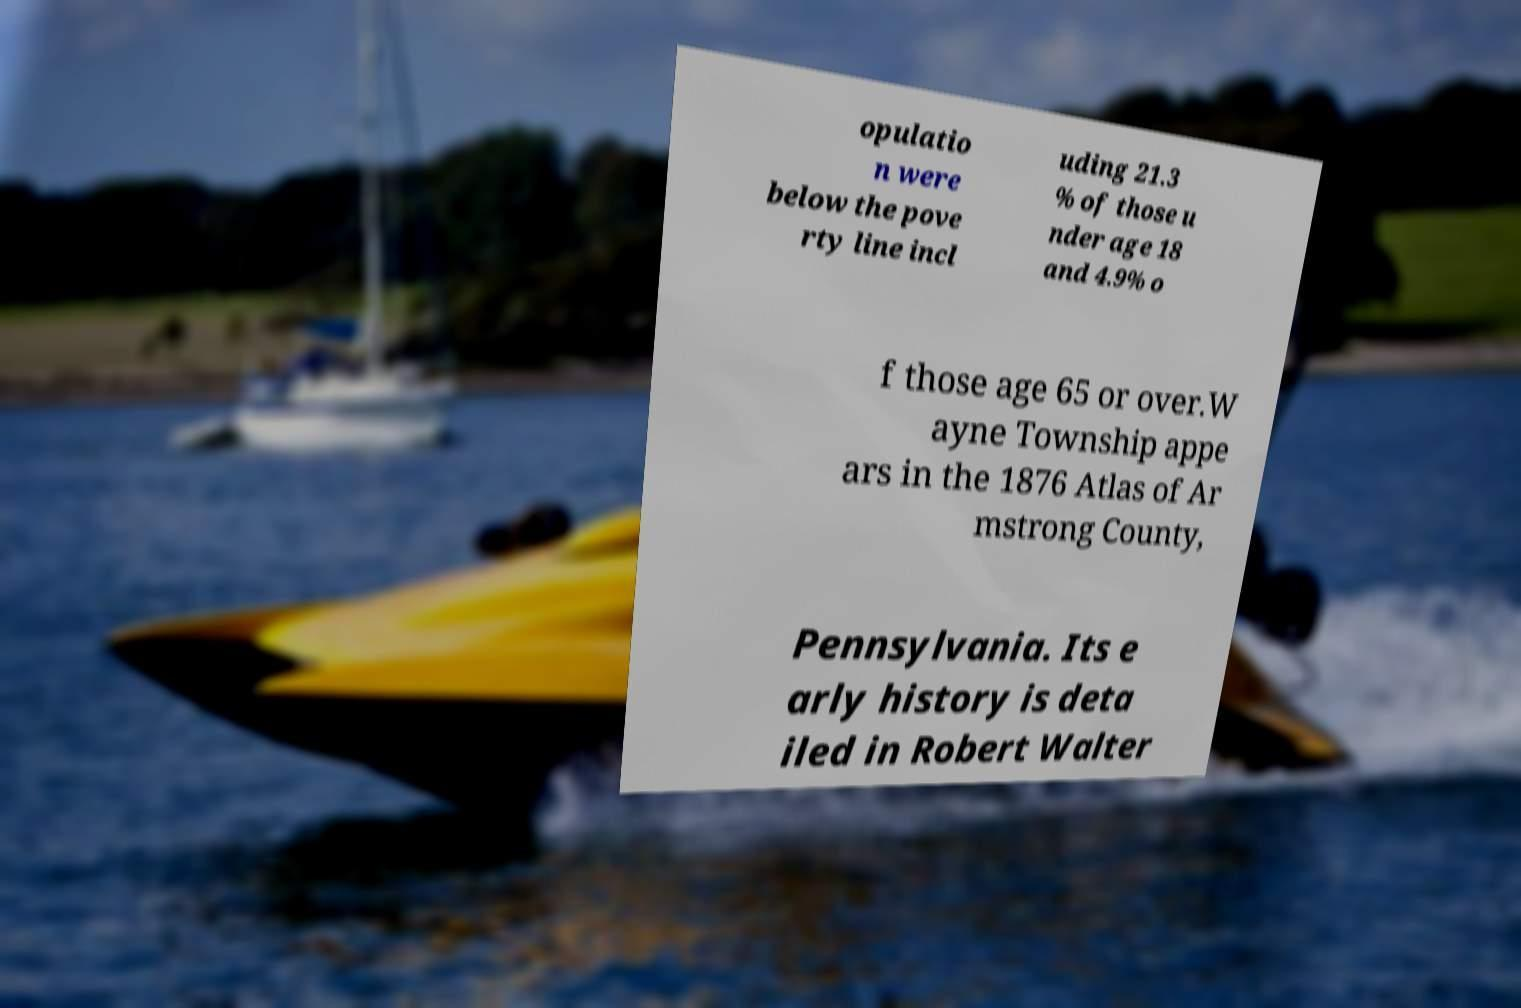Please read and relay the text visible in this image. What does it say? opulatio n were below the pove rty line incl uding 21.3 % of those u nder age 18 and 4.9% o f those age 65 or over.W ayne Township appe ars in the 1876 Atlas of Ar mstrong County, Pennsylvania. Its e arly history is deta iled in Robert Walter 